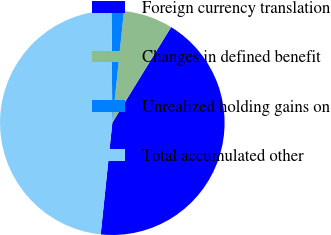<chart> <loc_0><loc_0><loc_500><loc_500><pie_chart><fcel>Foreign currency translation<fcel>Changes in defined benefit<fcel>Unrealized holding gains on<fcel>Total accumulated other<nl><fcel>42.88%<fcel>7.12%<fcel>1.77%<fcel>48.23%<nl></chart> 